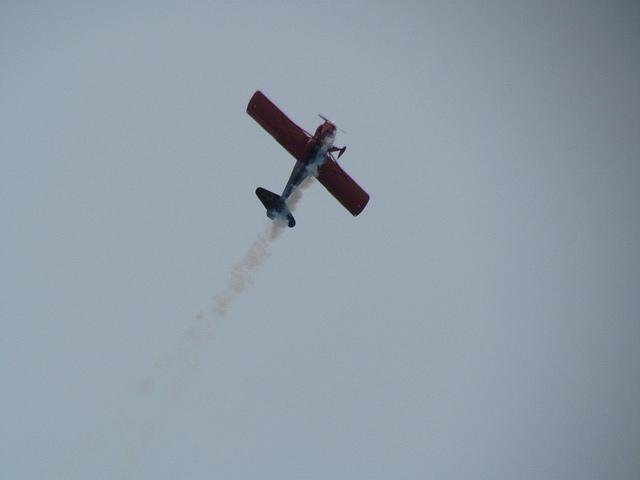How many engines does the plane have?
Give a very brief answer. 1. How many jets are there?
Give a very brief answer. 0. 